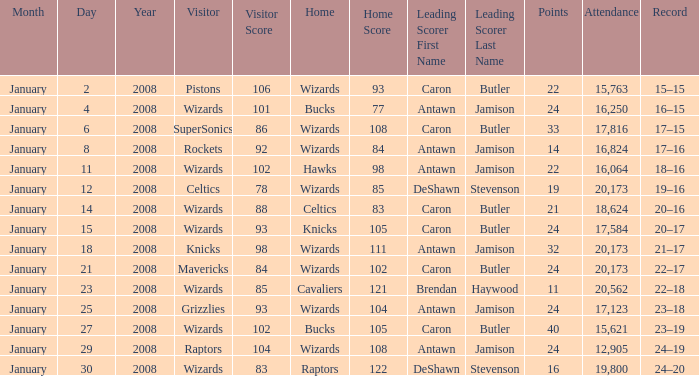How many people were in attendance on January 4, 2008? 16250.0. 